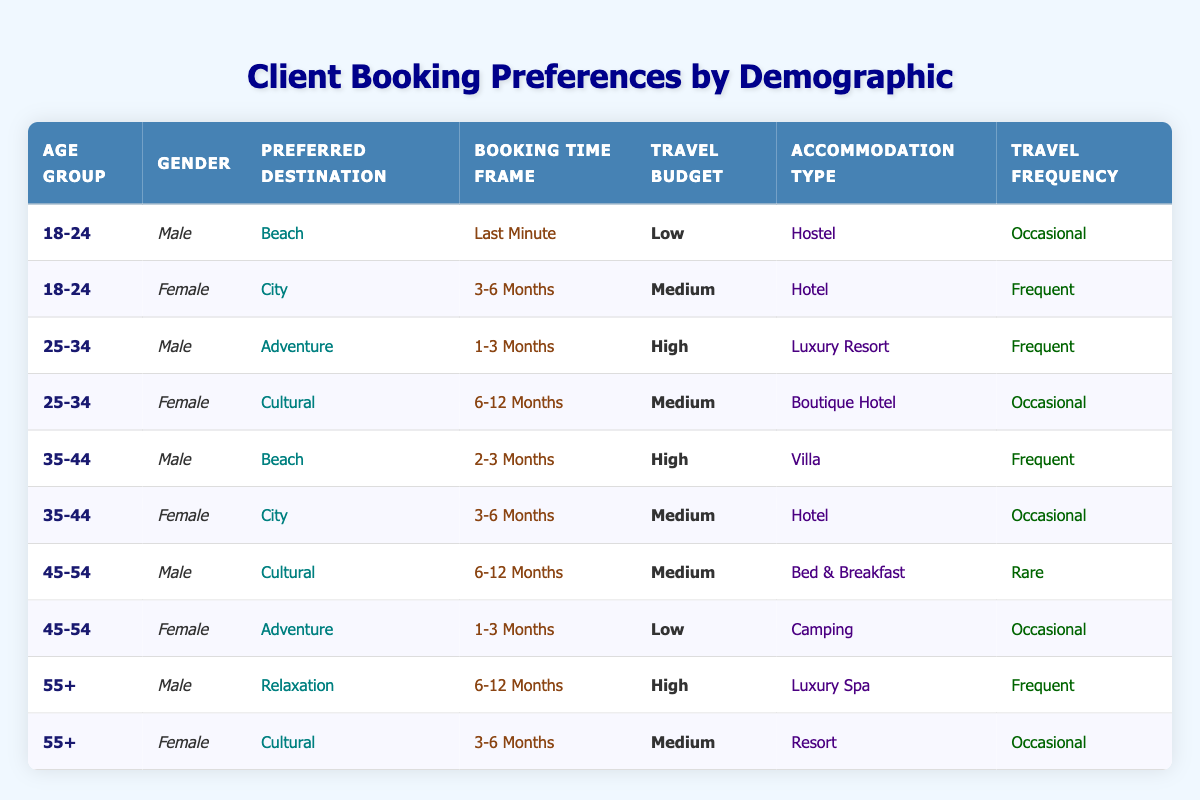What is the preferred destination of 18-24-year-old males? From the table, I can look at the row where the age group is "18-24" and the gender is "Male." In that row, the preferred destination is listed as "Beach."
Answer: Beach How many males prefer a "High" travel budget? To answer this, I need to scan all the rows for males and count how many have "High" in the travel budget column. There are three males with a high budget: one in the 25-34 age group, one in the 35-44 age group, and one in the 55+ age group.
Answer: 3 Do any female clients prefer "Camping" as their accommodation type? I look for rows where the gender is "Female" and check the accommodation type. One row matches this condition, where a 45-54-year-old female has "Camping" as her accommodation type.
Answer: Yes What percentage of clients in the 25-34 age group prefer "Adventure" or "Cultural" destinations? There are four clients in the 25-34 age group. I've identified that one prefers "Adventure" and one prefers "Cultural." To get the percentage, I calculate (2/4) * 100 = 50%.
Answer: 50% Is the accommodation type "Luxury Spa" preferred by any female clients? I review the table for any females in the accommodation type column. The row where the accommodation type is "Luxury Spa" corresponds to the male in the 55+ age group. Thus, no females prefer "Luxury Spa."
Answer: No Which booking time frame is most common among clients aged 35-44? Checking the relevant rows for clients aged 35-44, I find that two clients share the booking time frame: "2-3 Months" for a male and "3-6 Months" for a female. Both time frames occur once. Thus, there is no predominant time frame for this age group.
Answer: None How many total clients prefer "Hotel" mentioned as their accommodation type? I can find the rows where the accommodation type is "Hotel." There are three clients who prefer "Hotel": one in the 18-24 age group, one in the 35-44 age group, and one in the 55+ age group.
Answer: 3 What is the average travel budget for clients in the 18-24 age group? The clients in the 18-24 group have one with a low budget and one with a medium budget. To find the average, I represent low as 1 and medium as 2, which totals 3, then divide by 2 to get 1.5. Thus, the average travel budget in this scenario is medium-low.
Answer: Medium Are there any clients who prefer "Cultural" destinations with a "Rare" travel frequency? I look for any rows with "Cultural" listed as the preferred destination and "Rare" as travel frequency. There is one such row: a 45-54-year-old male who has "Cultural" as the preferred destination and a "Rare" travel frequency.
Answer: Yes 